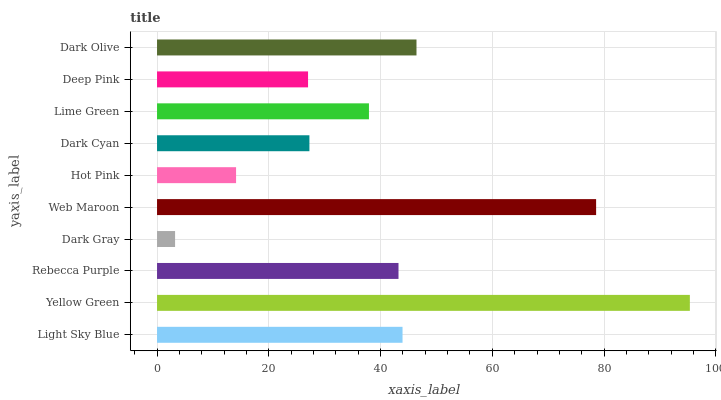Is Dark Gray the minimum?
Answer yes or no. Yes. Is Yellow Green the maximum?
Answer yes or no. Yes. Is Rebecca Purple the minimum?
Answer yes or no. No. Is Rebecca Purple the maximum?
Answer yes or no. No. Is Yellow Green greater than Rebecca Purple?
Answer yes or no. Yes. Is Rebecca Purple less than Yellow Green?
Answer yes or no. Yes. Is Rebecca Purple greater than Yellow Green?
Answer yes or no. No. Is Yellow Green less than Rebecca Purple?
Answer yes or no. No. Is Rebecca Purple the high median?
Answer yes or no. Yes. Is Lime Green the low median?
Answer yes or no. Yes. Is Dark Gray the high median?
Answer yes or no. No. Is Yellow Green the low median?
Answer yes or no. No. 